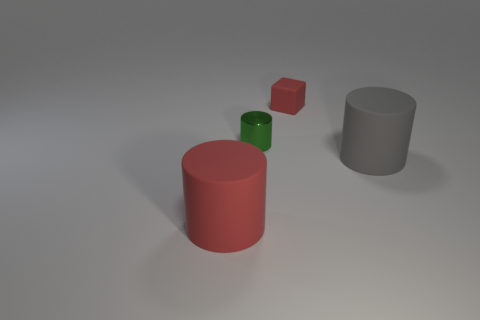What number of objects are both in front of the tiny red matte object and right of the metal cylinder?
Give a very brief answer. 1. Do the red rubber block and the gray matte object have the same size?
Ensure brevity in your answer.  No. Is the size of the green object left of the red block the same as the tiny red matte block?
Provide a succinct answer. Yes. What color is the big rubber object to the right of the metallic thing?
Provide a succinct answer. Gray. What number of green shiny spheres are there?
Your response must be concise. 0. The large gray thing that is the same material as the small red cube is what shape?
Offer a terse response. Cylinder. There is a big matte thing on the left side of the metal object; is it the same color as the small object that is right of the green metal cylinder?
Offer a terse response. Yes. Is the number of small cubes behind the red rubber cylinder the same as the number of cylinders?
Give a very brief answer. No. How many small green metallic things are in front of the small cylinder?
Your answer should be compact. 0. The shiny object has what size?
Give a very brief answer. Small. 